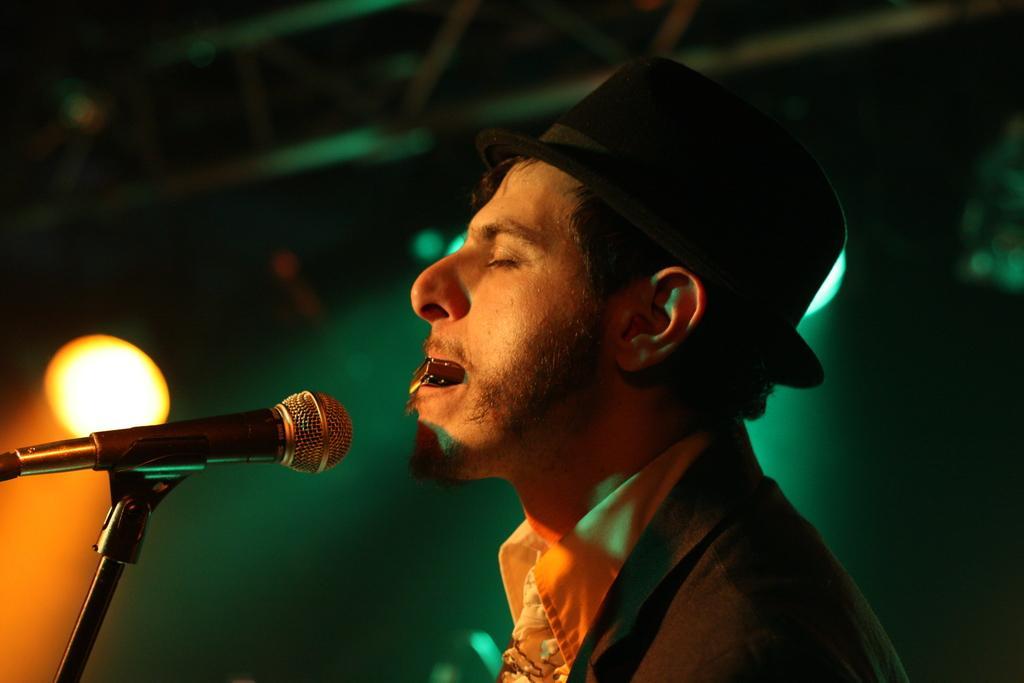In one or two sentences, can you explain what this image depicts? In this picture there is a man holding an object and wore hat, in front of him we can see a microphone with stand. In the background of the image it is dark and we can see lights. 